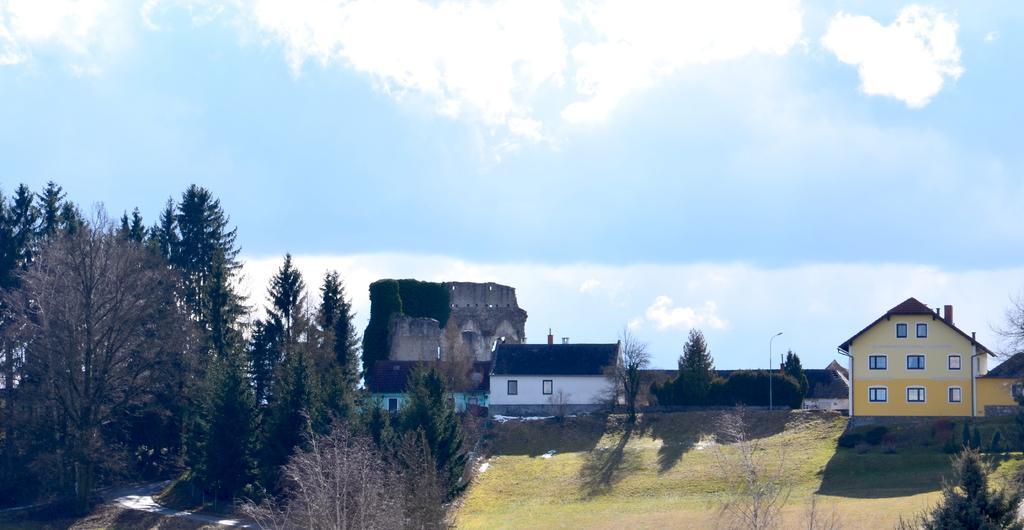Describe this image in one or two sentences. In this image we can see some houses, windows, light pole, plants, trees, also we can see the sky. 